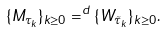<formula> <loc_0><loc_0><loc_500><loc_500>\{ M _ { \tau _ { k } } \} _ { k \geq 0 } = ^ { d } \{ W _ { \tilde { \tau } _ { k } } \} _ { k \geq 0 } .</formula> 